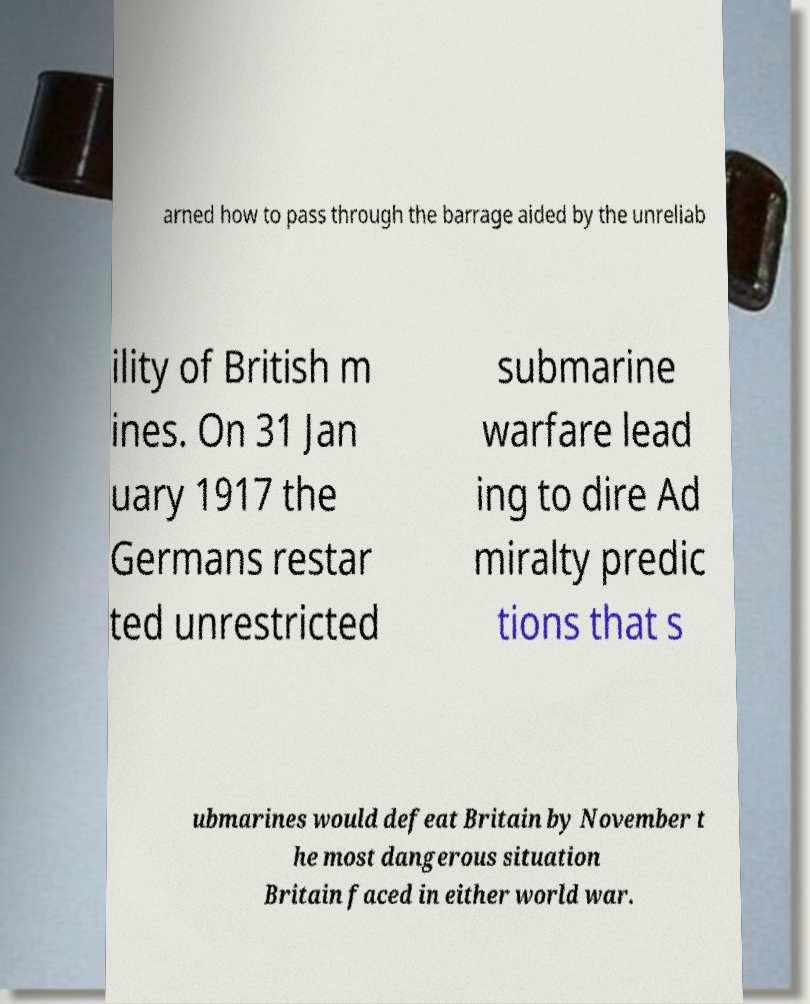Could you extract and type out the text from this image? arned how to pass through the barrage aided by the unreliab ility of British m ines. On 31 Jan uary 1917 the Germans restar ted unrestricted submarine warfare lead ing to dire Ad miralty predic tions that s ubmarines would defeat Britain by November t he most dangerous situation Britain faced in either world war. 